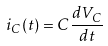Convert formula to latex. <formula><loc_0><loc_0><loc_500><loc_500>i _ { C } ( t ) = C \frac { d V _ { C } } { d t }</formula> 